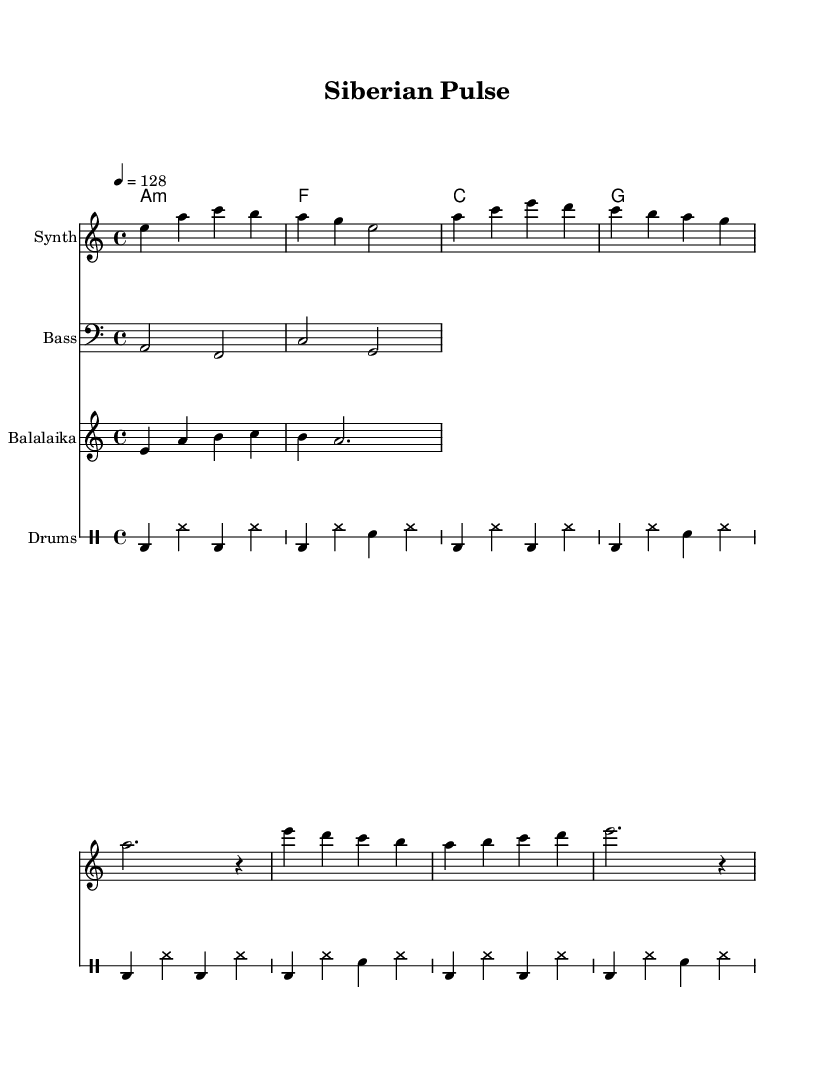What is the key signature of this music? The key signature is A minor, which has no sharps or flats.
Answer: A minor What is the time signature of this music? The time signature is 4/4, which means there are four beats in each measure.
Answer: 4/4 What is the tempo of the piece? The tempo is indicated as quarter note equals 128 beats per minute, representing a lively pace.
Answer: 128 How many measures are in the intro section? The intro section consists of 2 measures, as indicated by the notation before the verse begins.
Answer: 2 Which instrument plays the melody? The melody is played by the synth as indicated by the staff label in the sheet music.
Answer: Synth How does the harmony progress throughout the piece? The harmony changes through the chord sequence: A minor, F major, C major, G major, creating a cycle that supports the melody.
Answer: A minor, F, C, G What unique instrument is featured in this piece? The balalaika is featured, a traditional Russian string instrument, which adds cultural depth to the electronic dance music.
Answer: Balalaika 